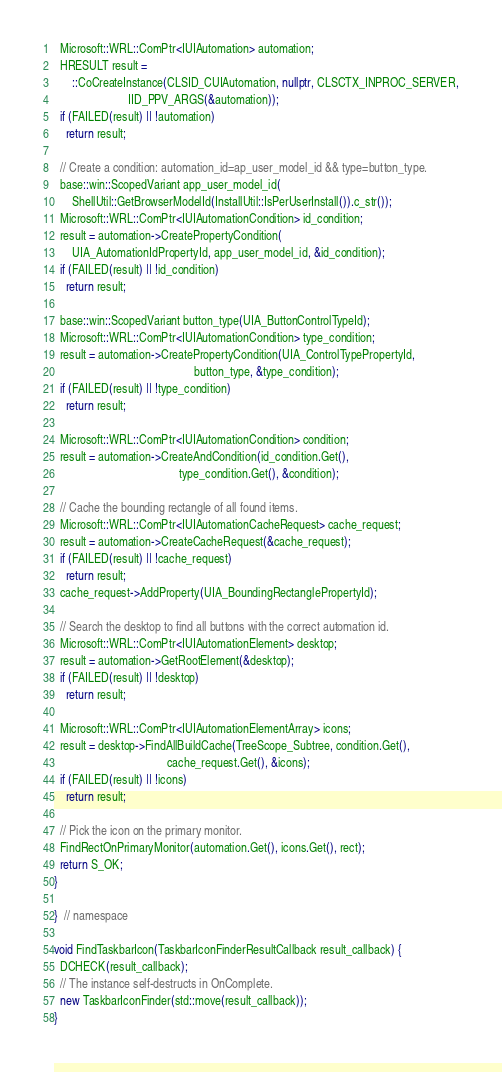Convert code to text. <code><loc_0><loc_0><loc_500><loc_500><_C++_>
  Microsoft::WRL::ComPtr<IUIAutomation> automation;
  HRESULT result =
      ::CoCreateInstance(CLSID_CUIAutomation, nullptr, CLSCTX_INPROC_SERVER,
                         IID_PPV_ARGS(&automation));
  if (FAILED(result) || !automation)
    return result;

  // Create a condition: automation_id=ap_user_model_id && type=button_type.
  base::win::ScopedVariant app_user_model_id(
      ShellUtil::GetBrowserModelId(InstallUtil::IsPerUserInstall()).c_str());
  Microsoft::WRL::ComPtr<IUIAutomationCondition> id_condition;
  result = automation->CreatePropertyCondition(
      UIA_AutomationIdPropertyId, app_user_model_id, &id_condition);
  if (FAILED(result) || !id_condition)
    return result;

  base::win::ScopedVariant button_type(UIA_ButtonControlTypeId);
  Microsoft::WRL::ComPtr<IUIAutomationCondition> type_condition;
  result = automation->CreatePropertyCondition(UIA_ControlTypePropertyId,
                                               button_type, &type_condition);
  if (FAILED(result) || !type_condition)
    return result;

  Microsoft::WRL::ComPtr<IUIAutomationCondition> condition;
  result = automation->CreateAndCondition(id_condition.Get(),
                                          type_condition.Get(), &condition);

  // Cache the bounding rectangle of all found items.
  Microsoft::WRL::ComPtr<IUIAutomationCacheRequest> cache_request;
  result = automation->CreateCacheRequest(&cache_request);
  if (FAILED(result) || !cache_request)
    return result;
  cache_request->AddProperty(UIA_BoundingRectanglePropertyId);

  // Search the desktop to find all buttons with the correct automation id.
  Microsoft::WRL::ComPtr<IUIAutomationElement> desktop;
  result = automation->GetRootElement(&desktop);
  if (FAILED(result) || !desktop)
    return result;

  Microsoft::WRL::ComPtr<IUIAutomationElementArray> icons;
  result = desktop->FindAllBuildCache(TreeScope_Subtree, condition.Get(),
                                      cache_request.Get(), &icons);
  if (FAILED(result) || !icons)
    return result;

  // Pick the icon on the primary monitor.
  FindRectOnPrimaryMonitor(automation.Get(), icons.Get(), rect);
  return S_OK;
}

}  // namespace

void FindTaskbarIcon(TaskbarIconFinderResultCallback result_callback) {
  DCHECK(result_callback);
  // The instance self-destructs in OnComplete.
  new TaskbarIconFinder(std::move(result_callback));
}
</code> 